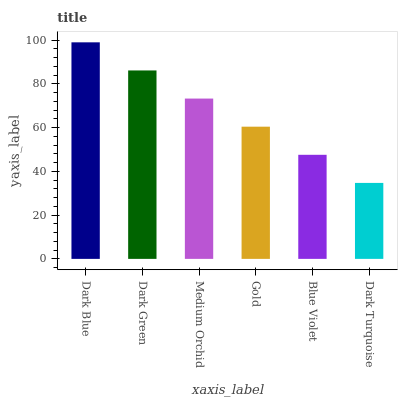Is Dark Green the minimum?
Answer yes or no. No. Is Dark Green the maximum?
Answer yes or no. No. Is Dark Blue greater than Dark Green?
Answer yes or no. Yes. Is Dark Green less than Dark Blue?
Answer yes or no. Yes. Is Dark Green greater than Dark Blue?
Answer yes or no. No. Is Dark Blue less than Dark Green?
Answer yes or no. No. Is Medium Orchid the high median?
Answer yes or no. Yes. Is Gold the low median?
Answer yes or no. Yes. Is Dark Green the high median?
Answer yes or no. No. Is Medium Orchid the low median?
Answer yes or no. No. 